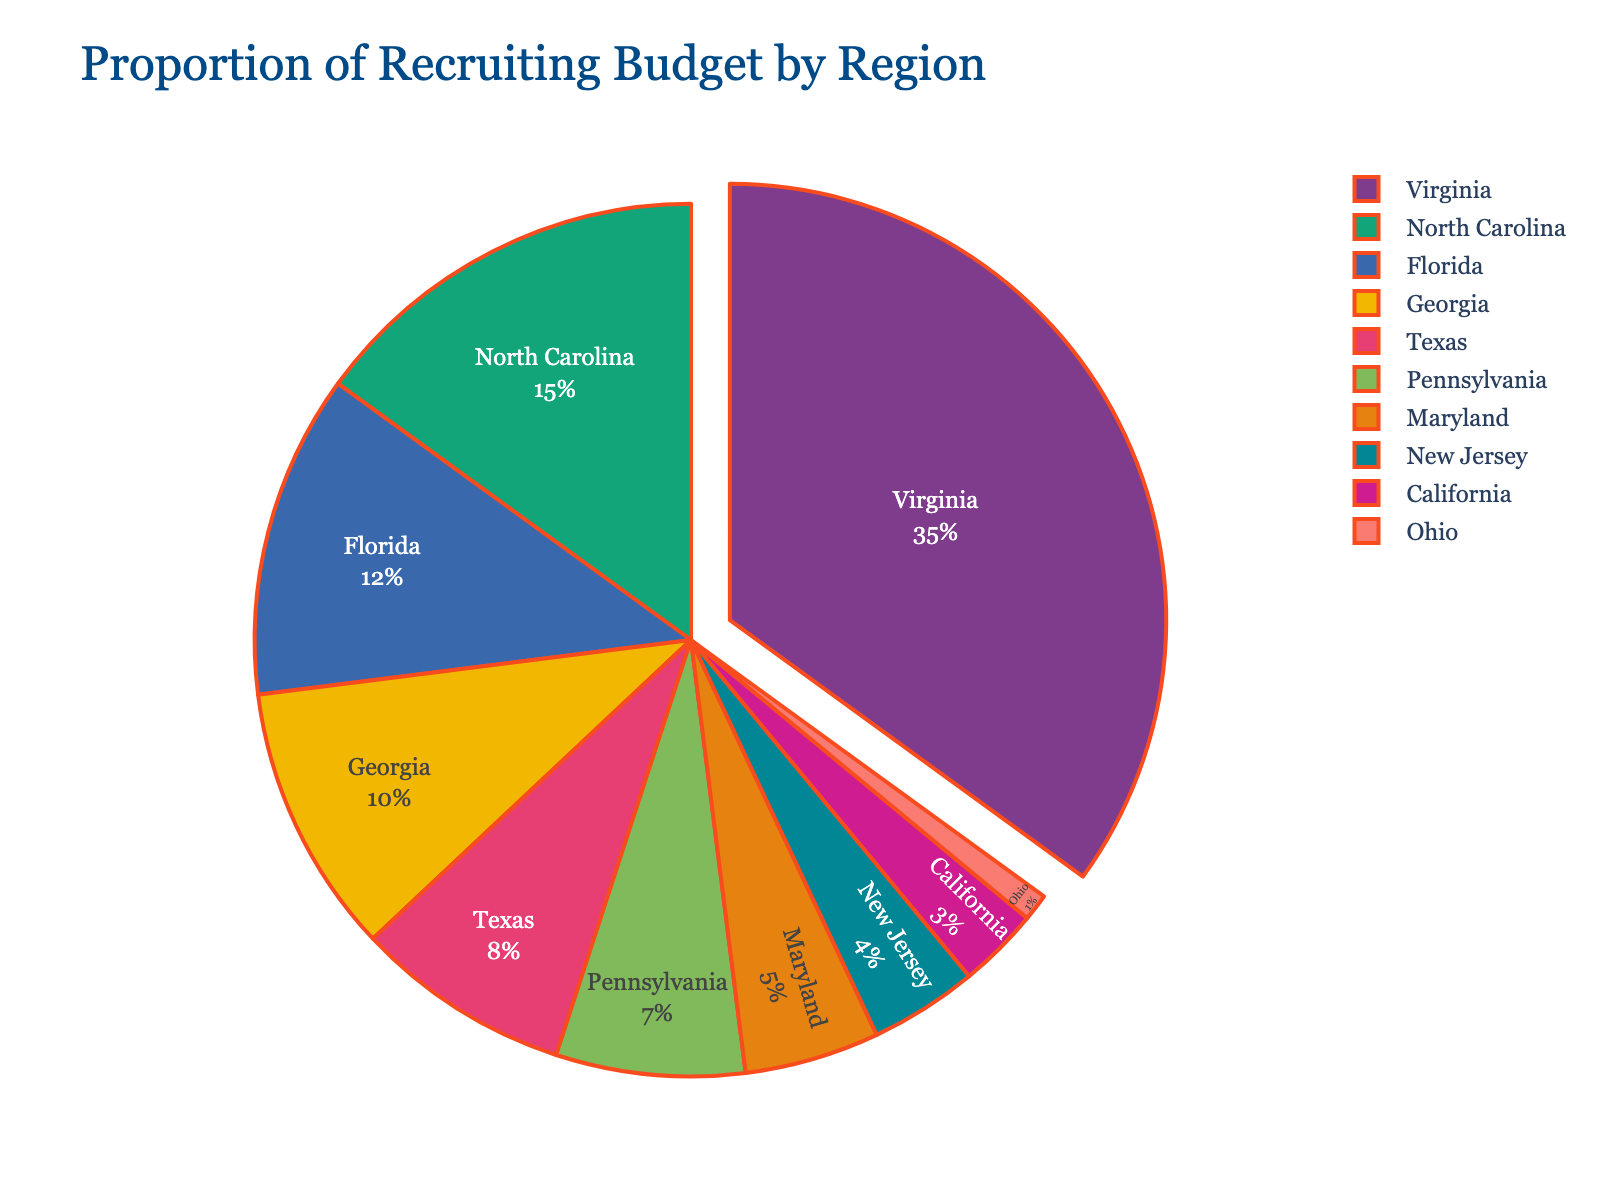Which region has the highest proportion of the recruiting budget? The figure shows various proportions, with the largest segment pulled out for emphasis. This segment corresponds to Virginia with 35%.
Answer: Virginia How much more of the recruiting budget is spent on Virginia compared to Georgia? Virginia accounts for 35% while Georgia accounts for 10%. The difference is calculated as 35% - 10% = 25%.
Answer: 25% What is the combined percentage of the recruiting budget spent on North Carolina and Florida? North Carolina accounts for 15% and Florida for 12%. Combined, they represent 15% + 12% = 27% of the budget.
Answer: 27% Which two regions have the smallest proportion of the recruiting budget, and what is their combined percentage? The two smallest segments on the chart are Ohio and California, with 1% and 3% respectively. Their combined percentage is 1% + 3% = 4%.
Answer: Ohio and California, 4% How does the recruiting budget spent on Texas compare to that spent on Pennsylvania? Texas accounts for 8% of the budget while Pennsylvania accounts for 7%. Texas has a slightly higher budget proportion by 1% more than Pennsylvania.
Answer: Texas has 1% more than Pennsylvania What percentage of the budget is spent on regions outside Virginia, North Carolina, and Florida? The combined percentage for Virginia, North Carolina, and Florida is 35% + 15% + 12% = 62%. Subtracting from 100%, the remaining percentage is 100% - 62% = 38%.
Answer: 38% What is the average budget percentage for the states of Texas, Pennsylvania, and Maryland? The percentages for Texas, Pennsylvania, and Maryland are 8%, 7%, and 5% respectively. The average is calculated as (8% + 7% + 5%) / 3 ≈ 6.67%.
Answer: 6.67% If the recruiting budget is \$1,000,000, how much is allocated to New Jersey? New Jersey accounts for 4% of the total budget. Thus, 4% of \$1,000,000 is \(\$1,000,000 \times 0.04 = \$40,000\).
Answer: \$40,000 What is the difference in the recruiting budget percentages between Maryland and Georgia? The pie chart shows Maryland with 5% and Georgia with 10%. The difference is 10% - 5% = 5%.
Answer: 5% If Ohio's budget were to be increased by 2%, what would be its new budget percentage, and how would this affect the total percentage for all regions? Ohio's current percentage is 1%. If increased by 2%, it would be 1% + 2% = 3%. The original total is 100%, so the new total would become 100% + 2% = 102%. Therefore, other regions' percentages would need to decrease to maintain a total of 100%.
Answer: 3%, other regions' percentages decrease to maintain 100% 